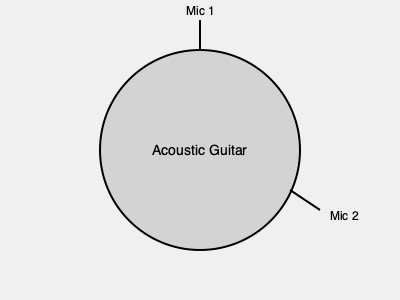In a professional recording studio setup for acoustic guitar, which microphone placement technique is most effective for capturing both the body resonance and string detail? To optimally record an acoustic guitar, we need to consider multiple factors:

1. Body resonance: This provides the warmth and fullness of the guitar's sound.
2. String detail: This captures the clarity and articulation of individual notes.

The most effective technique for capturing both aspects is the XY stereo pair technique with the following setup:

Step 1: Place Mic 1 (as shown in the diagram) about 6-12 inches from the 12th fret of the guitar, angled slightly towards the sound hole. This position captures the string detail and some of the body resonance.

Step 2: Position Mic 2 (as shown in the diagram) near the bridge of the guitar, angled towards the lower bout. This mic captures more of the body resonance and overall guitar tone.

Step 3: Ensure both mics are at a 90-degree angle to each other, forming an XY configuration.

Step 4: Adjust the distance of both mics from the guitar to balance the proximity effect and room ambience.

This XY stereo pair technique provides:
- A balanced stereo image
- Excellent phase coherence
- A blend of string detail and body resonance

By using this technique, you capture a full, natural sound of the acoustic guitar that can be easily adjusted in the mix to suit the needs of your revolutionary music production studio.
Answer: XY stereo pair technique 